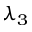Convert formula to latex. <formula><loc_0><loc_0><loc_500><loc_500>\lambda _ { 3 }</formula> 